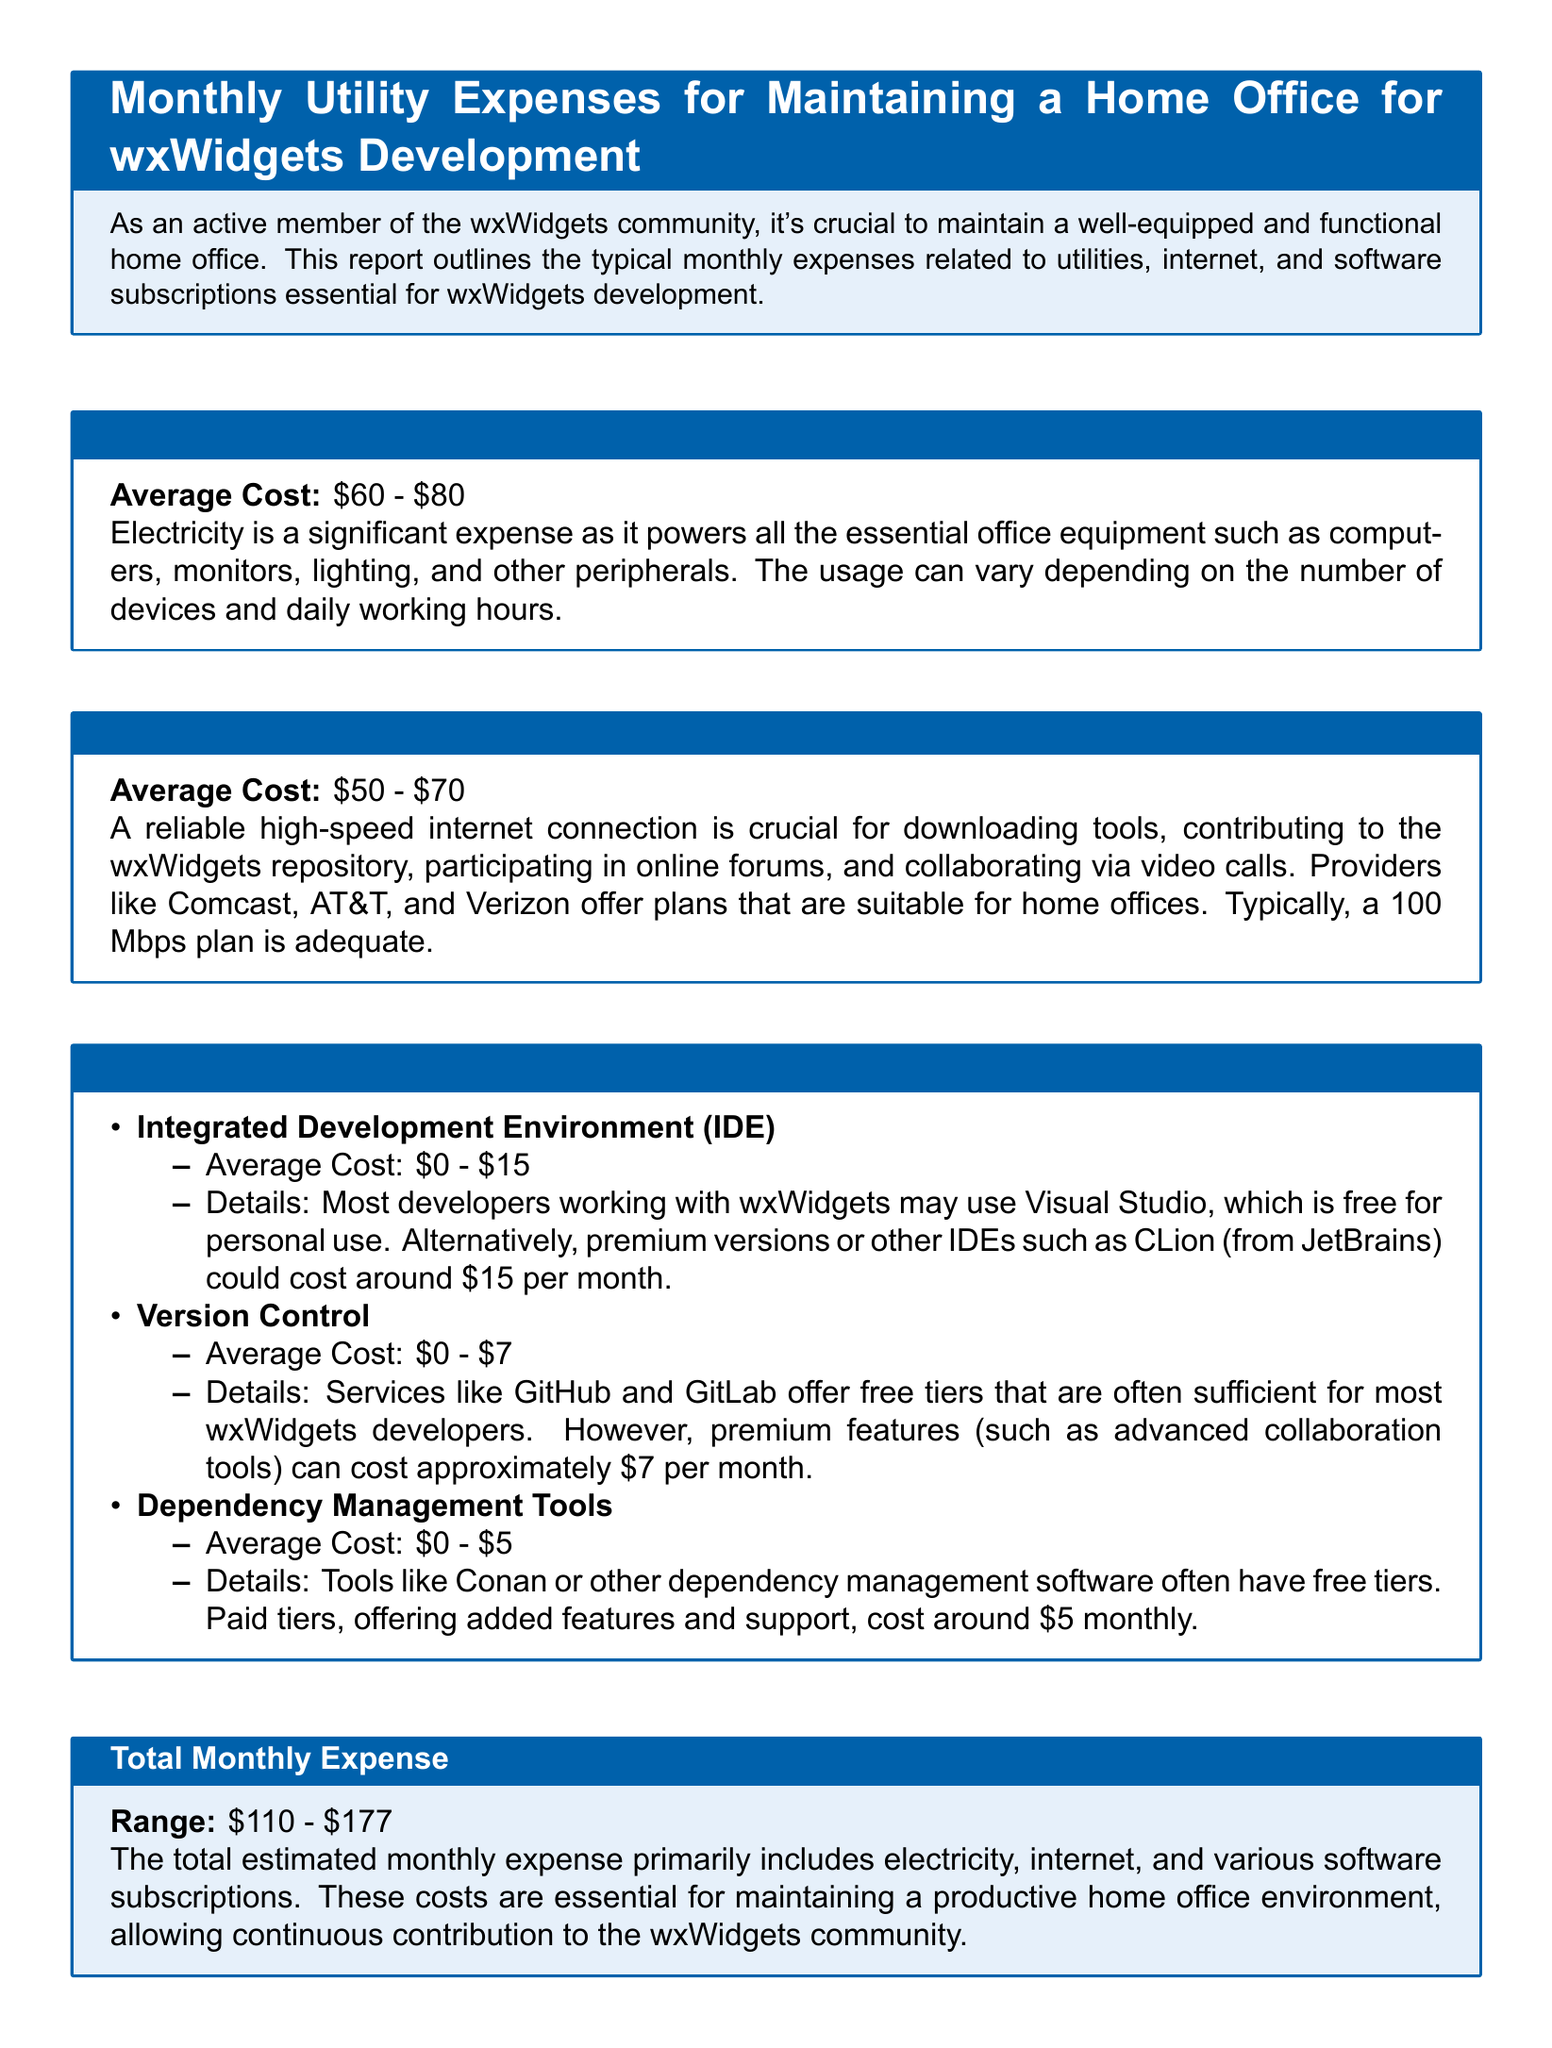what is the average cost of electricity? The average cost of electricity is stated in the document as \$60 - \$80.
Answer: \$60 - \$80 what is the average cost of internet? The average cost of internet is given as \$50 - \$70.
Answer: \$50 - \$70 what is the total estimated monthly expense? The total estimated monthly expense is summarized at the end of the document as a range that combines all expenses.
Answer: \$110 - \$177 what is one software subscription mentioned for dependency management tools? The document lists dependency management tools and provides examples.
Answer: Conan what is the average cost for a version control subscription? The document specifies the average cost for version control services.
Answer: \$0 - \$7 why is electricity considered a significant expense in the report? The report notes the importance of electricity for powering essential office equipment, explaining the variability in costs.
Answer: It powers essential office equipment what is a typical internet speed mentioned as adequate for home offices? The document indicates a recommended internet plan speed for home offices.
Answer: 100 Mbps what is the average cost of an Integrated Development Environment (IDE)? The document states the average cost for using an IDE for wxWidgets development.
Answer: \$0 - \$15 